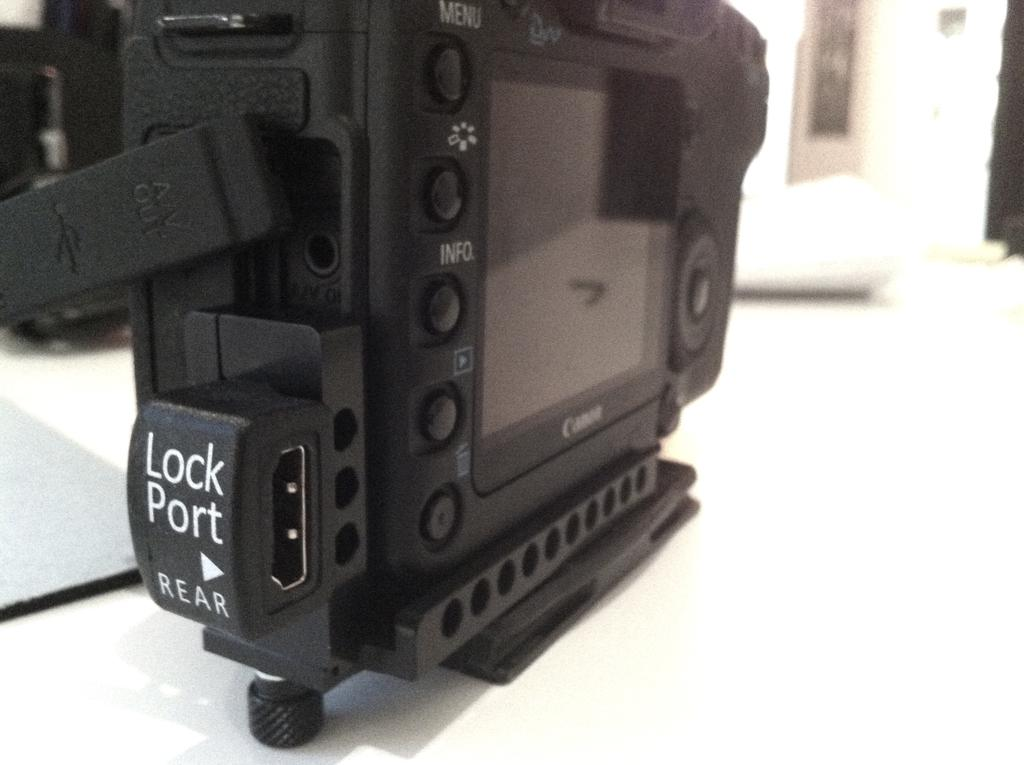What object is the main subject of the image? There is a camera in the image. Where is the camera located in the image? The camera is on a surface. What team is responsible for the idea behind the camera in the image? There is no information about a team or idea related to the camera in the image. The image only shows a camera on a surface. 